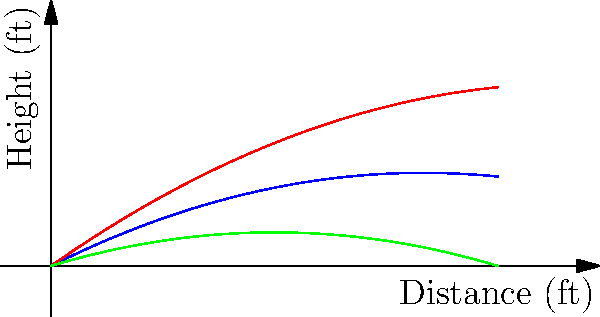A pitcher throws three fastballs with identical initial velocities but different spin rates. The graph shows the trajectories of these pitches. Which color represents the pitch with the highest spin rate, and how does increased spin rate affect the ball's trajectory compared to a normal spin pitch? To answer this question, we need to understand the relationship between spin rate and a baseball's trajectory:

1. Magnus effect: The spin of a baseball creates a pressure difference, resulting in a force perpendicular to the direction of motion.

2. For a fastball with backspin:
   - Higher spin rate increases the upward force
   - Lower spin rate decreases the upward force

3. Analyzing the graph:
   - Blue line: represents normal spin (middle trajectory)
   - Red line: shows the highest trajectory
   - Green line: shows the lowest trajectory

4. Effects of spin rate:
   - The red line (highest trajectory) corresponds to the highest spin rate
   - Higher spin rate results in more "lift," keeping the ball elevated longer
   - Lower spin rate (green line) results in less lift, causing the ball to drop faster

5. Comparison to normal spin:
   - High spin (red) stays above the normal spin trajectory
   - Low spin (green) falls below the normal spin trajectory

Therefore, the red line represents the pitch with the highest spin rate. Increased spin rate causes the ball to maintain a higher trajectory compared to a normal spin pitch, effectively resisting gravity for a longer time.
Answer: Red; increased spin rate causes the ball to maintain a higher trajectory. 